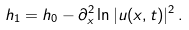<formula> <loc_0><loc_0><loc_500><loc_500>h _ { 1 } = h _ { 0 } - \partial _ { x } ^ { 2 } \ln | u ( x , t ) | ^ { 2 } \, .</formula> 